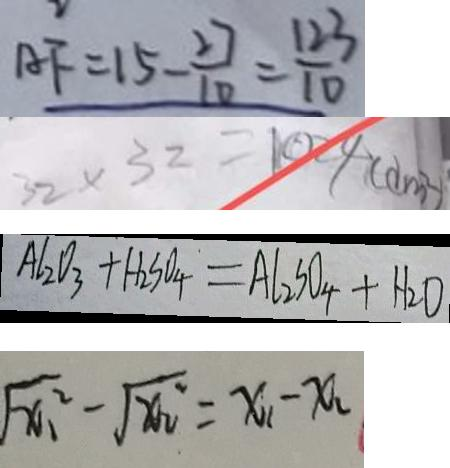Convert formula to latex. <formula><loc_0><loc_0><loc_500><loc_500>A F = 1 5 - \frac { 2 7 } { 1 0 } = \frac { 1 2 3 } { 1 0 } 
 3 2 \times 3 2 = 1 0 2 4 ( d m ^ { 2 } ) 
 A l _ { 2 } O _ { 3 } + H _ { 2 } S O _ { 4 } = A l _ { 2 } S O _ { 4 } + H _ { 2 } O 
 \sqrt { x _ { 1 } ^ { 2 } } - \sqrt { x _ { 2 } ^ { 2 } } = x _ { 1 } - x _ { 2 }</formula> 